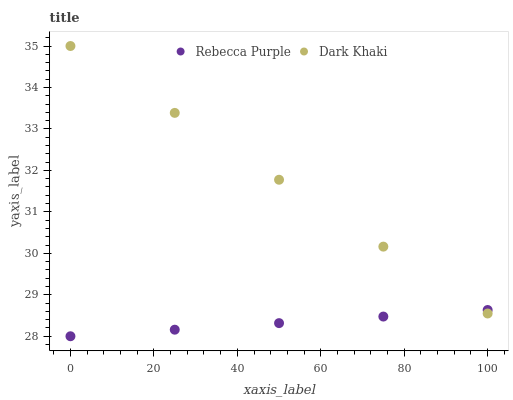Does Rebecca Purple have the minimum area under the curve?
Answer yes or no. Yes. Does Dark Khaki have the maximum area under the curve?
Answer yes or no. Yes. Does Rebecca Purple have the maximum area under the curve?
Answer yes or no. No. Is Dark Khaki the smoothest?
Answer yes or no. Yes. Is Rebecca Purple the roughest?
Answer yes or no. Yes. Is Rebecca Purple the smoothest?
Answer yes or no. No. Does Rebecca Purple have the lowest value?
Answer yes or no. Yes. Does Dark Khaki have the highest value?
Answer yes or no. Yes. Does Rebecca Purple have the highest value?
Answer yes or no. No. Does Rebecca Purple intersect Dark Khaki?
Answer yes or no. Yes. Is Rebecca Purple less than Dark Khaki?
Answer yes or no. No. Is Rebecca Purple greater than Dark Khaki?
Answer yes or no. No. 